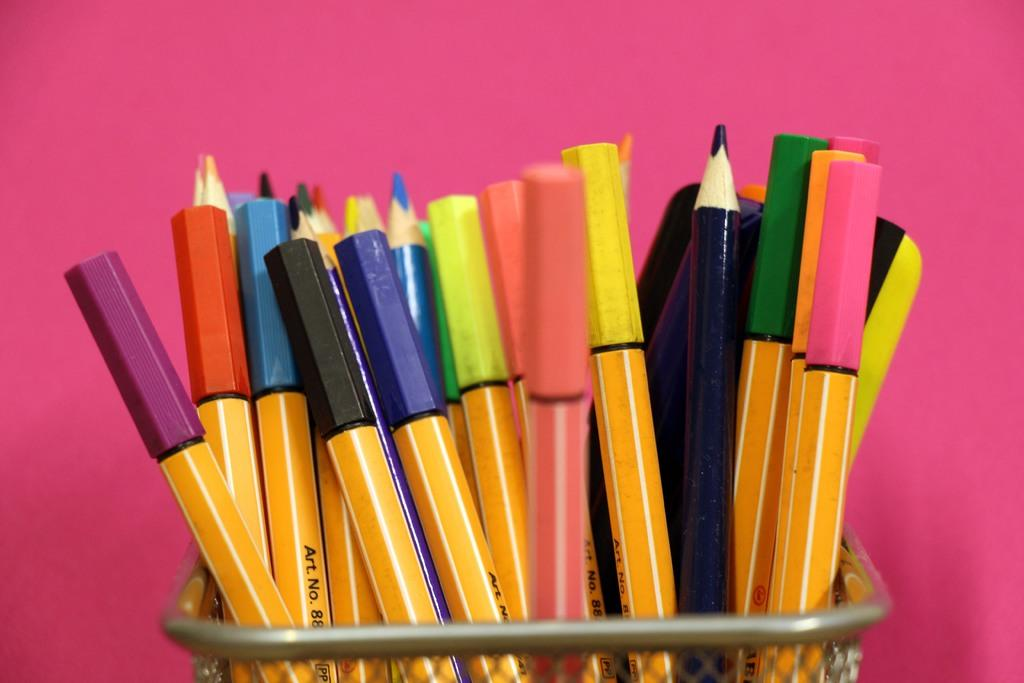What object is in the image that holds writing instruments? There is a metal pen pot in the image. What types of writing instruments are inside the pen pot? There are pens and pencils in the pen pot. What color is the background of the image? The background of the image is pink in color. What type of haircut does the pen pot have in the image? The pen pot does not have a haircut, as it is an inanimate object. 